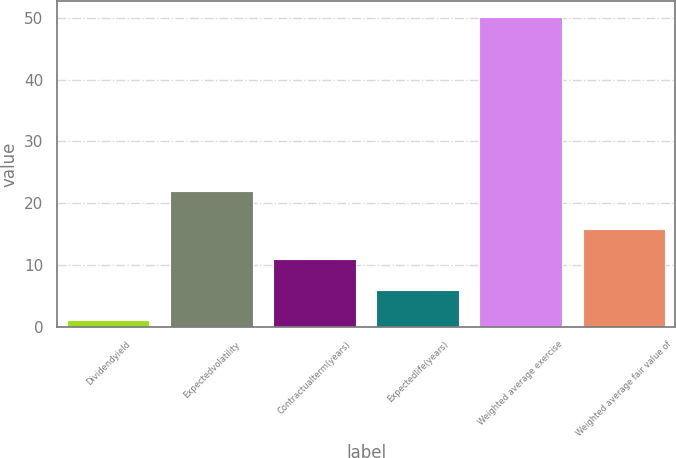Convert chart. <chart><loc_0><loc_0><loc_500><loc_500><bar_chart><fcel>Dividendyield<fcel>Expectedvolatility<fcel>Contractualterm(years)<fcel>Expectedlife(years)<fcel>Weighted average exercise<fcel>Weighted average fair value of<nl><fcel>1.04<fcel>22<fcel>10.92<fcel>6<fcel>50.21<fcel>15.84<nl></chart> 